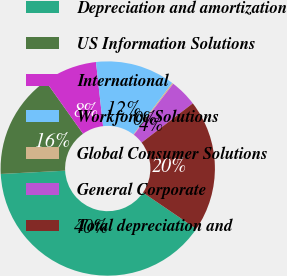<chart> <loc_0><loc_0><loc_500><loc_500><pie_chart><fcel>Depreciation and amortization<fcel>US Information Solutions<fcel>International<fcel>Workforce Solutions<fcel>Global Consumer Solutions<fcel>General Corporate<fcel>Total depreciation and<nl><fcel>39.67%<fcel>15.98%<fcel>8.08%<fcel>12.03%<fcel>0.19%<fcel>4.13%<fcel>19.93%<nl></chart> 